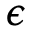<formula> <loc_0><loc_0><loc_500><loc_500>\epsilon</formula> 